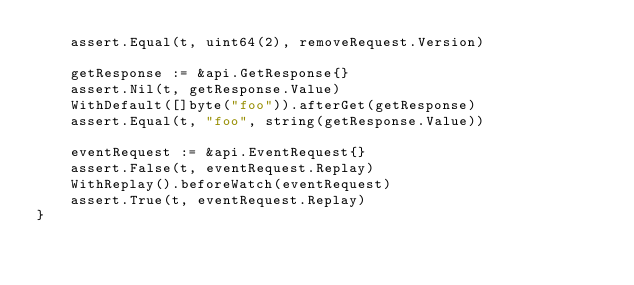<code> <loc_0><loc_0><loc_500><loc_500><_Go_>	assert.Equal(t, uint64(2), removeRequest.Version)

	getResponse := &api.GetResponse{}
	assert.Nil(t, getResponse.Value)
	WithDefault([]byte("foo")).afterGet(getResponse)
	assert.Equal(t, "foo", string(getResponse.Value))

	eventRequest := &api.EventRequest{}
	assert.False(t, eventRequest.Replay)
	WithReplay().beforeWatch(eventRequest)
	assert.True(t, eventRequest.Replay)
}
</code> 